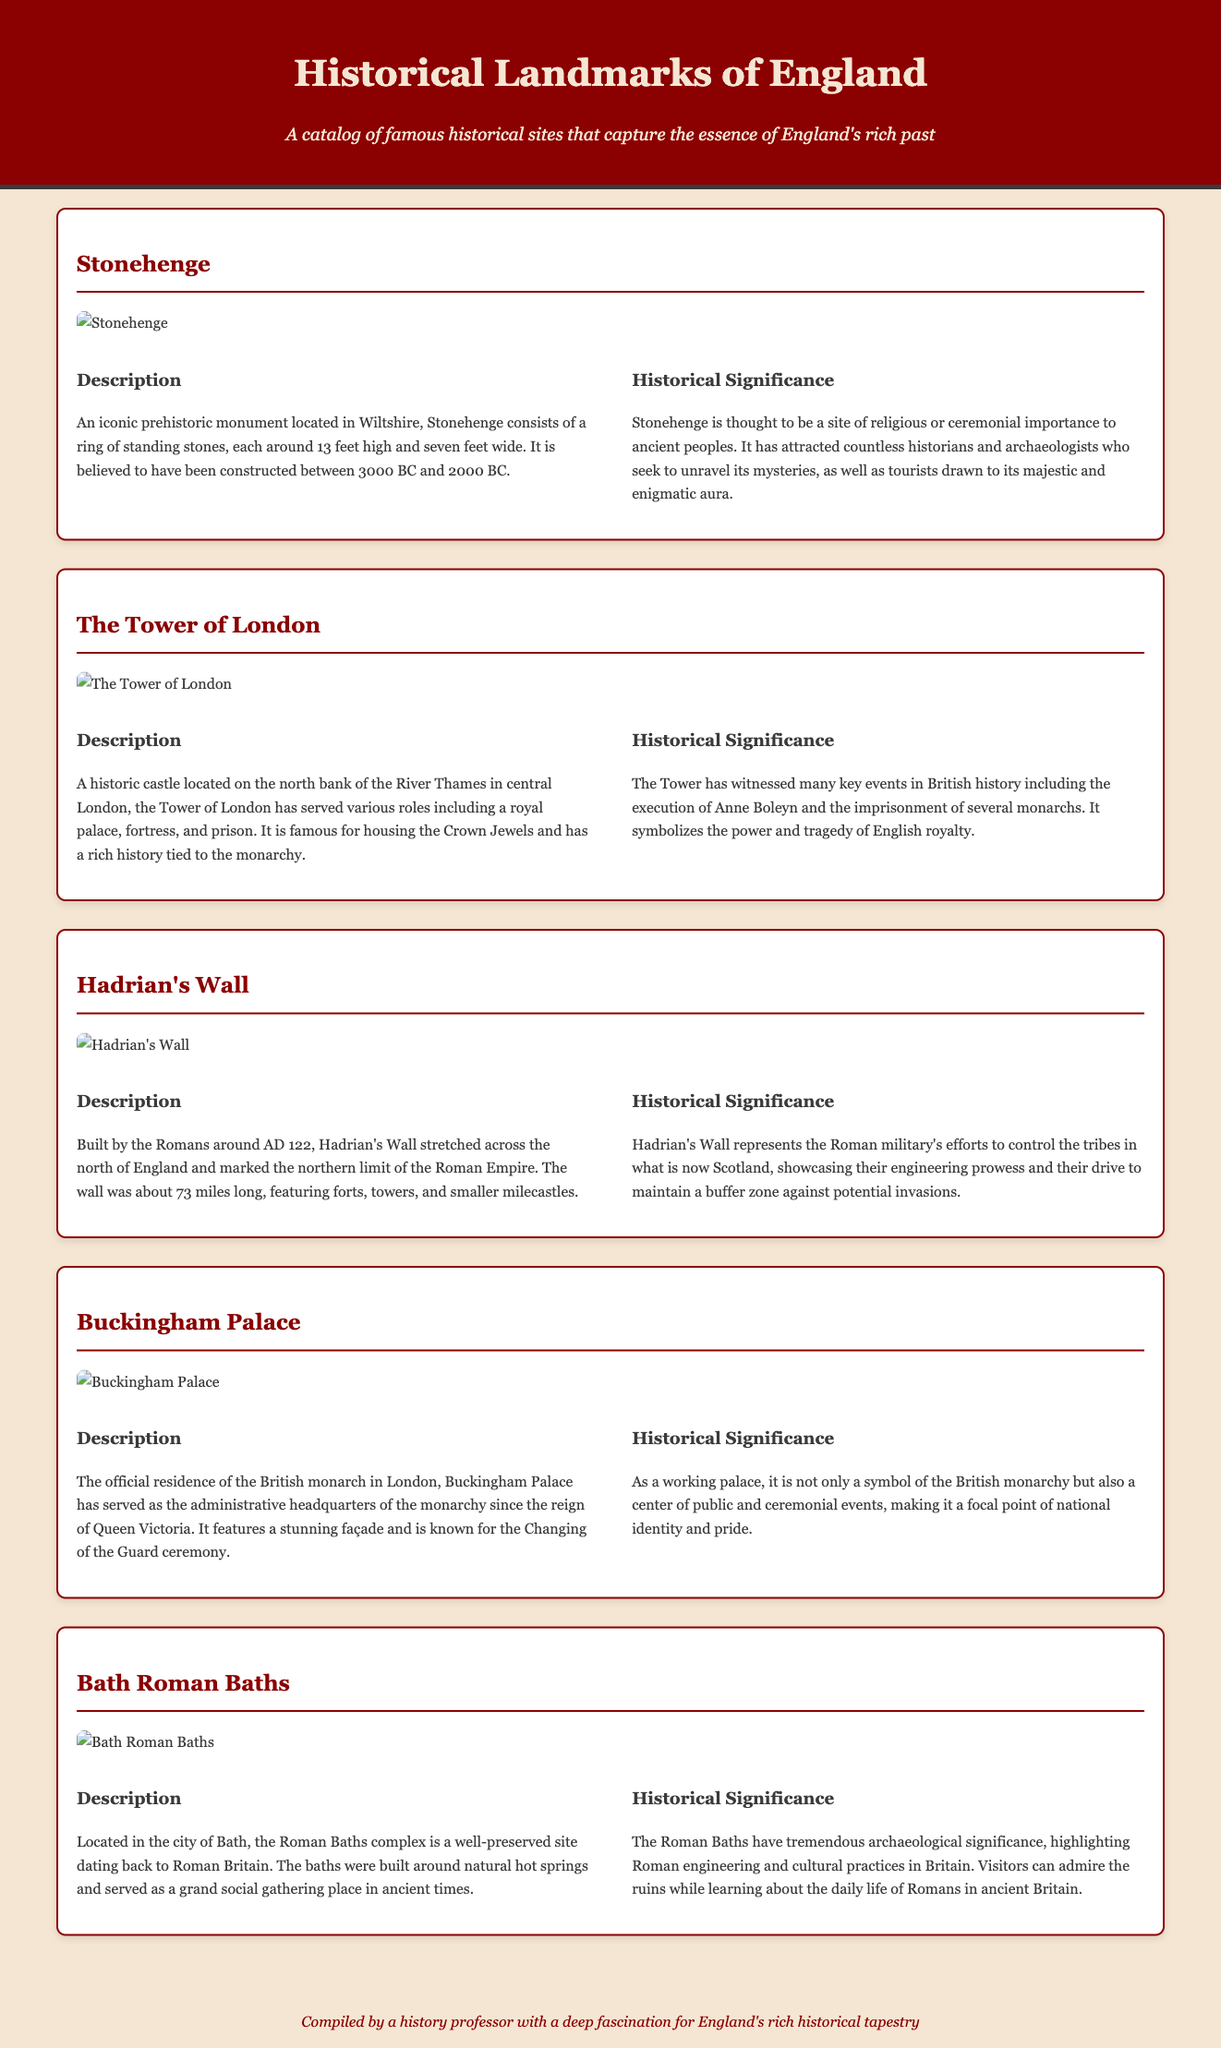What is the height of the stones at Stonehenge? Stonehenge consists of standing stones each around 13 feet high.
Answer: 13 feet What is the historical significance of the Tower of London? The Tower of London symbolizes the power and tragedy of English royalty and has witnessed many key events in British history.
Answer: Power and tragedy of English royalty When was Hadrian’s Wall built? Hadrian's Wall was built by the Romans around AD 122.
Answer: AD 122 What is the official residence of the British monarch in London? The official residence of the British monarch in London is Buckingham Palace.
Answer: Buckingham Palace How long did Hadrian's Wall stretch across England? Hadrian's Wall stretched about 73 miles long.
Answer: 73 miles What natural feature is associated with the Bath Roman Baths? The Roman Baths in Bath were built around natural hot springs.
Answer: Natural hot springs What event is famously associated with Buckingham Palace? Buckingham Palace is known for the Changing of the Guard ceremony.
Answer: Changing of the Guard ceremony What role did the Tower of London serve besides being a fortress? The Tower of London also served as a royal palace and prison.
Answer: Royal palace and prison What notable event involved Anne Boleyn at the Tower of London? Anne Boleyn was executed at the Tower of London.
Answer: Execution of Anne Boleyn 